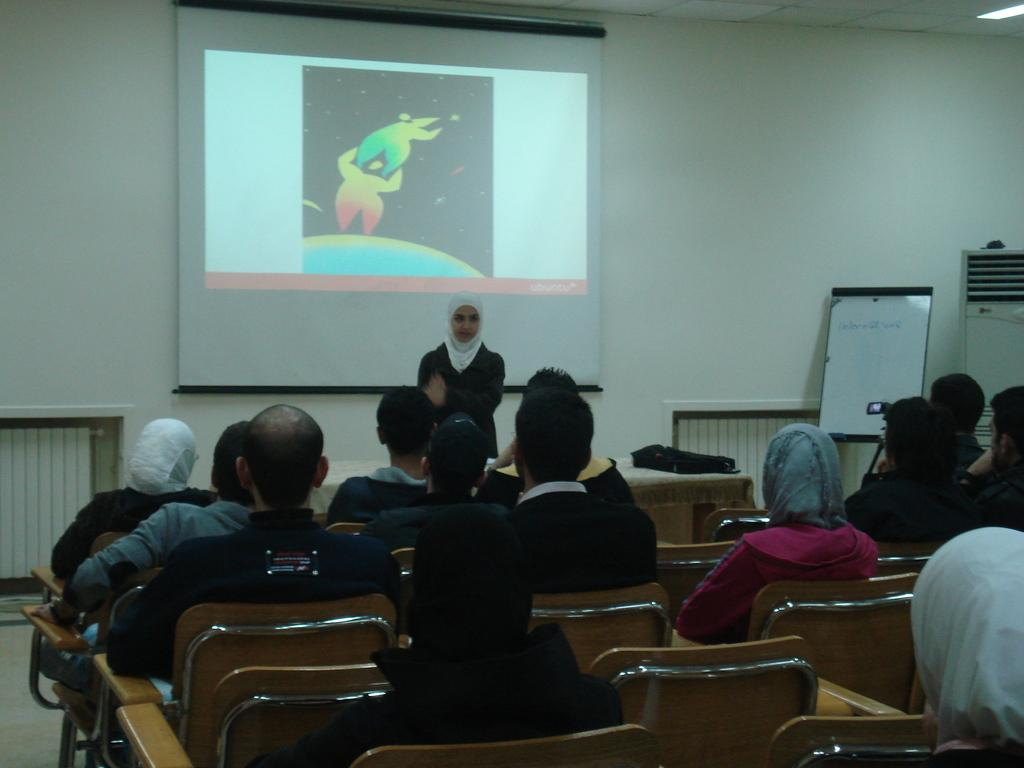What are the people in the image doing? The people in the image are sitting on chairs. Is there anyone standing in the image? Yes, there is a person standing in the image. What can be seen in the background of the image? There is a projector's screen in the background of the image. What color is the ink on the grandmother's hand in the image? There is no grandmother or ink present in the image. 